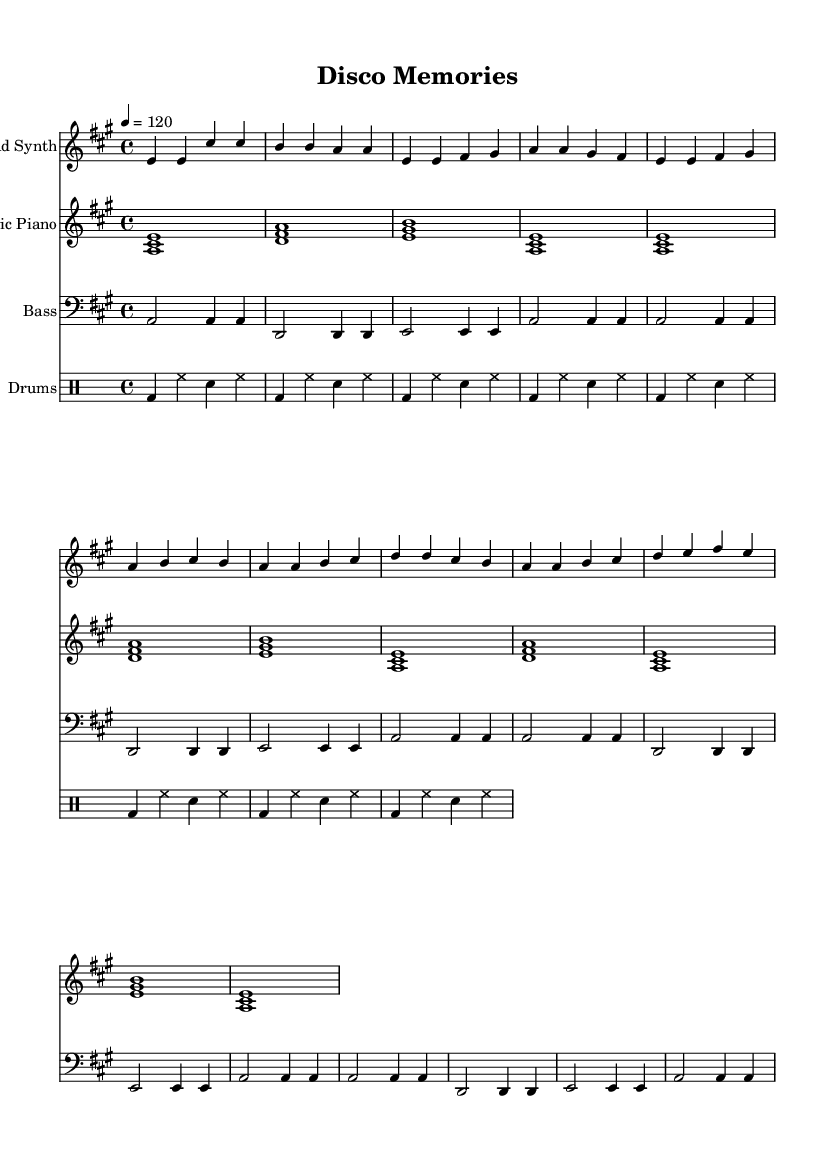What is the key signature of this music? The key signature is A major, which consists of three sharps (F#, C#, and G#). This can be determined by looking at the key signature indication at the beginning of the piece.
Answer: A major What is the time signature of this music? The time signature is 4/4, indicating four beats per measure and a quarter note gets one beat. This information is located at the beginning of the sheet music.
Answer: 4/4 What is the tempo marking for this piece? The tempo marking is quarter note equals 120, which means the piece should be played at 120 beats per minute. This can be found next to the tempo indication at the start of the score.
Answer: 120 How many measures are there in the lead synth part? Counting the measures in the lead synth part shows a total of 16 measures, which can be done by counting each set of bars until the end of the section.
Answer: 16 What instrument plays the bass pattern? The bass pattern is played by the bass guitar, as indicated by the instrument name above the corresponding staff in the sheet music.
Answer: Bass How many times is the bass pattern repeated in the score? The bass pattern is repeated three times as indicated by the "repeat unfold 3" marking, which shows that the section should be performed three additional times after the first occurrence.
Answer: 3 What chords are used in the chorus section? The chords used in the chorus are D, A, E, and A, as identified from the chord symbols above the staff during the chorus section of the electric piano part.
Answer: D, A, E, A 